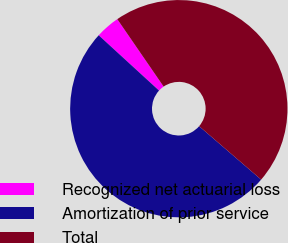Convert chart. <chart><loc_0><loc_0><loc_500><loc_500><pie_chart><fcel>Recognized net actuarial loss<fcel>Amortization of prior service<fcel>Total<nl><fcel>3.61%<fcel>50.49%<fcel>45.9%<nl></chart> 